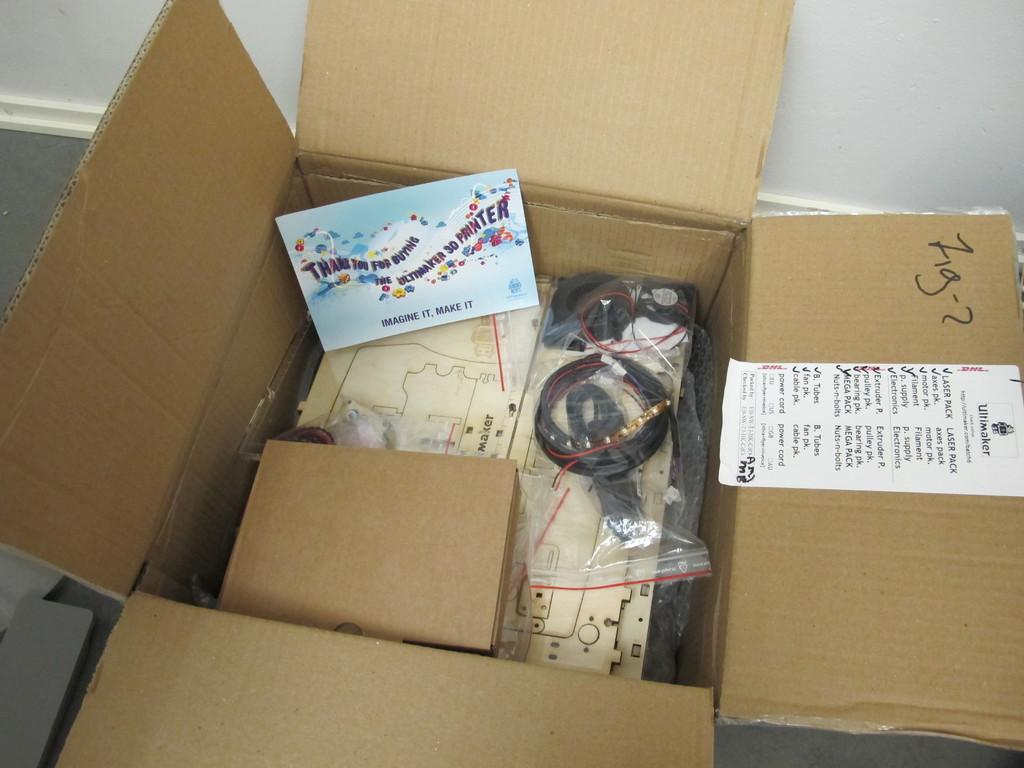<image>
Share a concise interpretation of the image provided. A thank you card was included in the box along with a 3D printer that says Imagine it, Make it. 